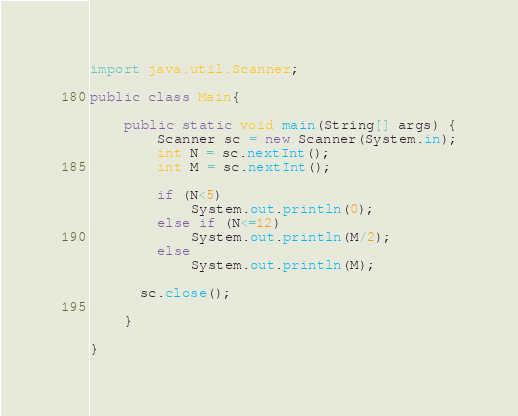<code> <loc_0><loc_0><loc_500><loc_500><_Java_>import java.util.Scanner;

public class Main{

	public static void main(String[] args) {
		Scanner sc = new Scanner(System.in);
	    int N = sc.nextInt();
	    int M = sc.nextInt();
	    
	    if (N<5)
	    	System.out.println(0);
	    else if (N<=12)
	    	System.out.println(M/2);
	    else
	    	System.out.println(M);
      
      sc.close();

	}

}
</code> 